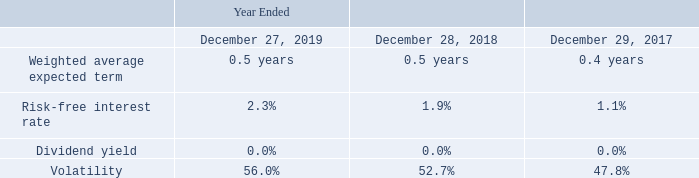2017 ESPP
In May 2017, we adopted the 2017 Employee Stock Purchase Plan (the “2017 ESPP”). The 2017 ESPP grants employees the ability to designate a portion of their base-pay to purchase ordinary shares at a price equal to 85% of the fair market value of our ordinary shares on the first or last day of each 6 month purchase period. Purchase periods begin on January 1 or July 1 and end on June 30 or December 31, or the next business day if such date is not a business day. Shares are purchased on the last day of the purchase period.
The table below sets forth the weighted average assumptions used to measure the fair value of 2017 ESPP rights:
We recognize share-based compensation expense associated with the 2017 ESPP over the duration of the purchase period. We recognized$0.3 million, $0.3 million, and $0.1 million of share-based compensation expense associated with the 2017 ESPP during 2019, 2018, and 2017, respectively. At December 27, 2019, there was no unrecognized share-based compensation expense.
When did the company adopt the 2017 Employee Stock Purchase Plan (the “2017 ESPP”)? May 2017. When are shares purchased? Shares are purchased on the last day of the purchase period. When do the purchase periods begin? January 1 or july 1. How many weighted average assumptions are used to measure the fair value of 2017 ESPP rights? Weighted average expected term##Risk-free interest rate##Dividend yield##Volatility
Answer: 4. What was the average risk-free interest rate for the 3 year period from 2017 to 2019?
Answer scale should be: percent. (2.3%+1.9%+1.1%)/(2019-2017+1)
Answer: 1.77. How many years during the 3 year period had volatility of greater than 50.0%? 56.0%##52.7%
Answer: 2. 